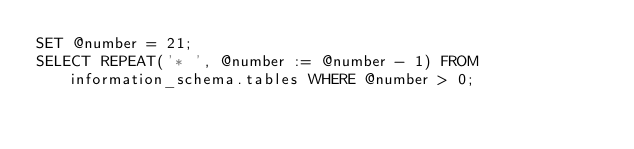Convert code to text. <code><loc_0><loc_0><loc_500><loc_500><_SQL_>SET @number = 21;
SELECT REPEAT('* ', @number := @number - 1) FROM information_schema.tables WHERE @number > 0;</code> 